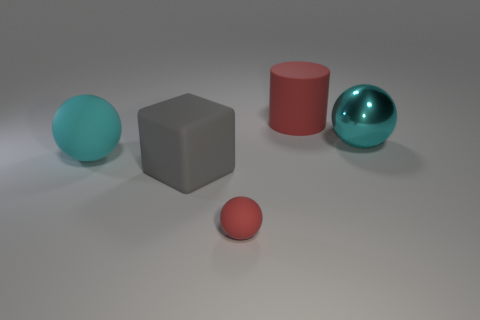How many things are tiny red matte things that are in front of the big cyan matte thing or red matte spheres?
Your answer should be compact. 1. What number of other objects are there of the same color as the small matte object?
Offer a terse response. 1. Are there an equal number of cyan spheres that are in front of the small red rubber thing and blue spheres?
Provide a succinct answer. Yes. There is a red object in front of the sphere to the right of the big red object; what number of small matte balls are left of it?
Make the answer very short. 0. Are there any other things that are the same size as the block?
Give a very brief answer. Yes. Is the size of the cyan shiny ball the same as the red object in front of the cyan metal ball?
Your answer should be very brief. No. How many red metal spheres are there?
Keep it short and to the point. 0. Do the cyan sphere that is to the right of the large cyan rubber object and the cyan object that is to the left of the cyan metal ball have the same size?
Offer a very short reply. Yes. What color is the big matte object that is the same shape as the tiny red rubber thing?
Offer a very short reply. Cyan. Is the gray rubber object the same shape as the shiny object?
Offer a terse response. No. 